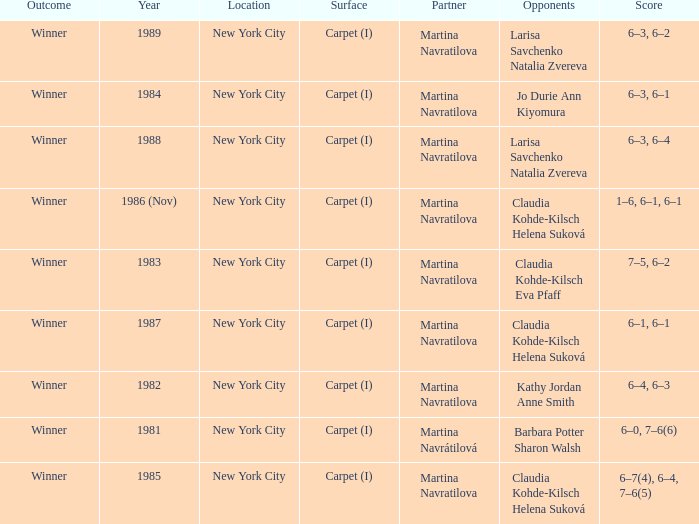Who were all of the opponents in 1984? Jo Durie Ann Kiyomura. 